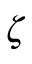<formula> <loc_0><loc_0><loc_500><loc_500>\zeta</formula> 